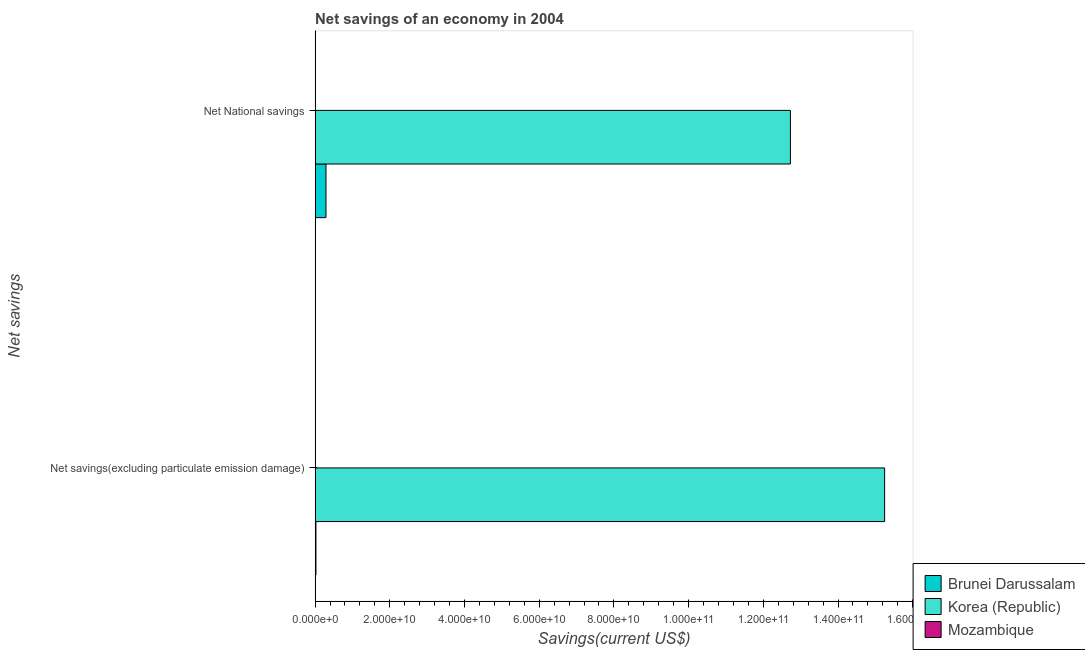How many different coloured bars are there?
Your response must be concise. 2. What is the label of the 1st group of bars from the top?
Your response must be concise. Net National savings. What is the net national savings in Brunei Darussalam?
Provide a succinct answer. 2.91e+09. Across all countries, what is the maximum net national savings?
Your answer should be compact. 1.27e+11. Across all countries, what is the minimum net savings(excluding particulate emission damage)?
Your answer should be very brief. 0. What is the total net national savings in the graph?
Give a very brief answer. 1.30e+11. What is the difference between the net national savings in Brunei Darussalam and that in Korea (Republic)?
Provide a short and direct response. -1.24e+11. What is the difference between the net national savings in Korea (Republic) and the net savings(excluding particulate emission damage) in Mozambique?
Keep it short and to the point. 1.27e+11. What is the average net savings(excluding particulate emission damage) per country?
Your response must be concise. 5.09e+1. What is the difference between the net national savings and net savings(excluding particulate emission damage) in Korea (Republic)?
Give a very brief answer. -2.52e+1. What is the ratio of the net savings(excluding particulate emission damage) in Brunei Darussalam to that in Korea (Republic)?
Your answer should be very brief. 0. In how many countries, is the net national savings greater than the average net national savings taken over all countries?
Give a very brief answer. 1. How many bars are there?
Your answer should be compact. 4. How many countries are there in the graph?
Keep it short and to the point. 3. What is the difference between two consecutive major ticks on the X-axis?
Offer a terse response. 2.00e+1. Does the graph contain grids?
Offer a very short reply. No. How many legend labels are there?
Keep it short and to the point. 3. What is the title of the graph?
Provide a short and direct response. Net savings of an economy in 2004. What is the label or title of the X-axis?
Provide a succinct answer. Savings(current US$). What is the label or title of the Y-axis?
Offer a terse response. Net savings. What is the Savings(current US$) in Brunei Darussalam in Net savings(excluding particulate emission damage)?
Your answer should be very brief. 2.27e+08. What is the Savings(current US$) in Korea (Republic) in Net savings(excluding particulate emission damage)?
Your answer should be compact. 1.52e+11. What is the Savings(current US$) in Brunei Darussalam in Net National savings?
Provide a short and direct response. 2.91e+09. What is the Savings(current US$) of Korea (Republic) in Net National savings?
Offer a very short reply. 1.27e+11. What is the Savings(current US$) of Mozambique in Net National savings?
Offer a terse response. 0. Across all Net savings, what is the maximum Savings(current US$) in Brunei Darussalam?
Provide a short and direct response. 2.91e+09. Across all Net savings, what is the maximum Savings(current US$) of Korea (Republic)?
Your response must be concise. 1.52e+11. Across all Net savings, what is the minimum Savings(current US$) in Brunei Darussalam?
Make the answer very short. 2.27e+08. Across all Net savings, what is the minimum Savings(current US$) in Korea (Republic)?
Keep it short and to the point. 1.27e+11. What is the total Savings(current US$) in Brunei Darussalam in the graph?
Your answer should be compact. 3.14e+09. What is the total Savings(current US$) of Korea (Republic) in the graph?
Offer a very short reply. 2.80e+11. What is the total Savings(current US$) in Mozambique in the graph?
Keep it short and to the point. 0. What is the difference between the Savings(current US$) of Brunei Darussalam in Net savings(excluding particulate emission damage) and that in Net National savings?
Your answer should be very brief. -2.69e+09. What is the difference between the Savings(current US$) in Korea (Republic) in Net savings(excluding particulate emission damage) and that in Net National savings?
Ensure brevity in your answer.  2.52e+1. What is the difference between the Savings(current US$) in Brunei Darussalam in Net savings(excluding particulate emission damage) and the Savings(current US$) in Korea (Republic) in Net National savings?
Offer a terse response. -1.27e+11. What is the average Savings(current US$) of Brunei Darussalam per Net savings?
Your answer should be very brief. 1.57e+09. What is the average Savings(current US$) in Korea (Republic) per Net savings?
Offer a very short reply. 1.40e+11. What is the difference between the Savings(current US$) in Brunei Darussalam and Savings(current US$) in Korea (Republic) in Net savings(excluding particulate emission damage)?
Keep it short and to the point. -1.52e+11. What is the difference between the Savings(current US$) of Brunei Darussalam and Savings(current US$) of Korea (Republic) in Net National savings?
Offer a very short reply. -1.24e+11. What is the ratio of the Savings(current US$) in Brunei Darussalam in Net savings(excluding particulate emission damage) to that in Net National savings?
Make the answer very short. 0.08. What is the ratio of the Savings(current US$) in Korea (Republic) in Net savings(excluding particulate emission damage) to that in Net National savings?
Offer a terse response. 1.2. What is the difference between the highest and the second highest Savings(current US$) of Brunei Darussalam?
Your response must be concise. 2.69e+09. What is the difference between the highest and the second highest Savings(current US$) of Korea (Republic)?
Your response must be concise. 2.52e+1. What is the difference between the highest and the lowest Savings(current US$) in Brunei Darussalam?
Your answer should be compact. 2.69e+09. What is the difference between the highest and the lowest Savings(current US$) of Korea (Republic)?
Offer a very short reply. 2.52e+1. 